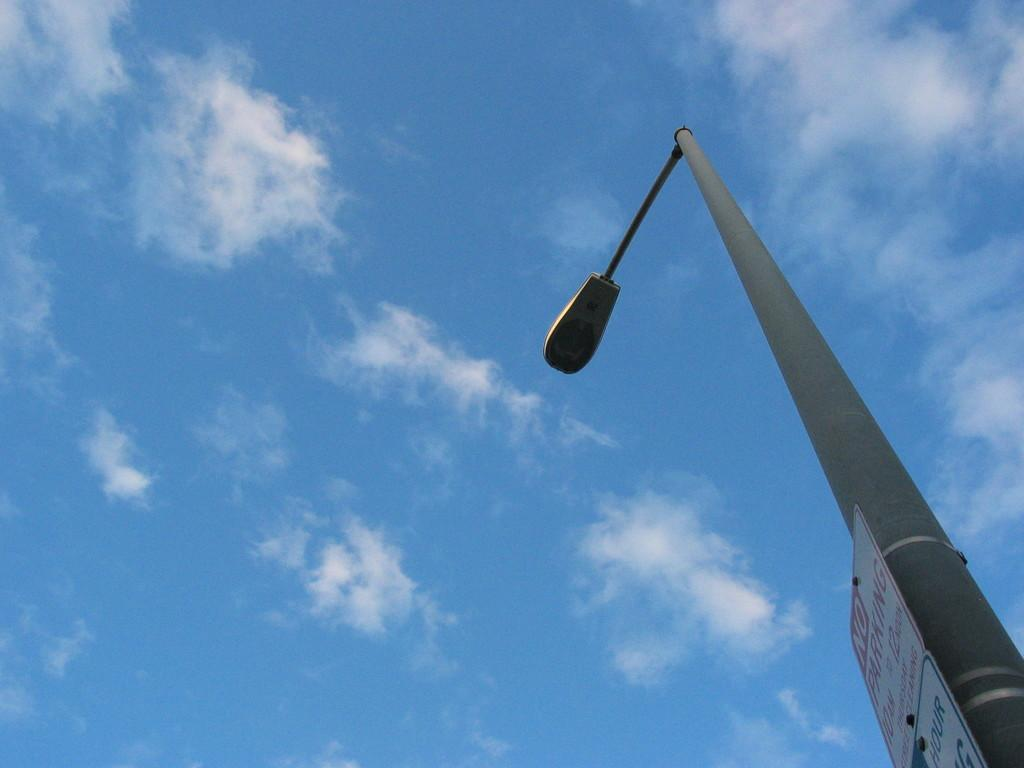What objects are present in the image that are made of boards? There are boards in the image. What type of light source is visible in the image? There is a light on a pole in the image. What is written or displayed on the boards? There is text on the boards. What can be seen in the sky in the image? The sky is visible at the top of the image, and there are clouds in the sky. How many children are playing with the fowl in the image? There are no children or fowl present in the image. What type of change is taking place in the image? There is no change taking place in the image; it is a static scene. 